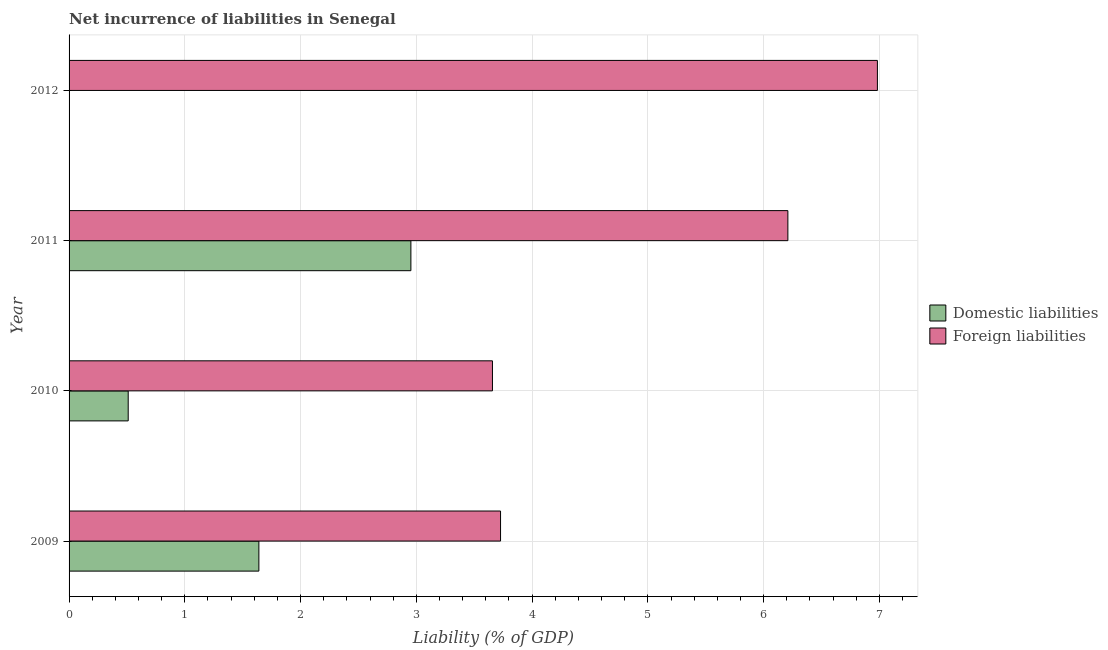How many different coloured bars are there?
Offer a terse response. 2. Are the number of bars per tick equal to the number of legend labels?
Provide a succinct answer. No. Are the number of bars on each tick of the Y-axis equal?
Give a very brief answer. No. In how many cases, is the number of bars for a given year not equal to the number of legend labels?
Offer a very short reply. 1. What is the incurrence of foreign liabilities in 2012?
Your response must be concise. 6.98. Across all years, what is the maximum incurrence of domestic liabilities?
Your answer should be compact. 2.95. In which year was the incurrence of foreign liabilities maximum?
Make the answer very short. 2012. What is the total incurrence of domestic liabilities in the graph?
Keep it short and to the point. 5.1. What is the difference between the incurrence of domestic liabilities in 2010 and that in 2011?
Provide a succinct answer. -2.44. What is the difference between the incurrence of foreign liabilities in 2011 and the incurrence of domestic liabilities in 2012?
Keep it short and to the point. 6.21. What is the average incurrence of domestic liabilities per year?
Offer a very short reply. 1.28. In the year 2011, what is the difference between the incurrence of domestic liabilities and incurrence of foreign liabilities?
Your response must be concise. -3.26. In how many years, is the incurrence of domestic liabilities greater than 6.6 %?
Your response must be concise. 0. What is the ratio of the incurrence of domestic liabilities in 2009 to that in 2010?
Your response must be concise. 3.21. Is the incurrence of foreign liabilities in 2009 less than that in 2010?
Provide a short and direct response. No. Is the difference between the incurrence of domestic liabilities in 2010 and 2011 greater than the difference between the incurrence of foreign liabilities in 2010 and 2011?
Give a very brief answer. Yes. What is the difference between the highest and the second highest incurrence of foreign liabilities?
Offer a terse response. 0.77. What is the difference between the highest and the lowest incurrence of foreign liabilities?
Your answer should be compact. 3.33. How many bars are there?
Give a very brief answer. 7. How many years are there in the graph?
Your answer should be compact. 4. What is the difference between two consecutive major ticks on the X-axis?
Provide a short and direct response. 1. Are the values on the major ticks of X-axis written in scientific E-notation?
Give a very brief answer. No. Does the graph contain any zero values?
Keep it short and to the point. Yes. Where does the legend appear in the graph?
Ensure brevity in your answer.  Center right. How many legend labels are there?
Provide a succinct answer. 2. What is the title of the graph?
Your answer should be very brief. Net incurrence of liabilities in Senegal. What is the label or title of the X-axis?
Keep it short and to the point. Liability (% of GDP). What is the Liability (% of GDP) in Domestic liabilities in 2009?
Your answer should be very brief. 1.64. What is the Liability (% of GDP) of Foreign liabilities in 2009?
Offer a terse response. 3.73. What is the Liability (% of GDP) of Domestic liabilities in 2010?
Make the answer very short. 0.51. What is the Liability (% of GDP) of Foreign liabilities in 2010?
Your response must be concise. 3.66. What is the Liability (% of GDP) in Domestic liabilities in 2011?
Provide a succinct answer. 2.95. What is the Liability (% of GDP) in Foreign liabilities in 2011?
Give a very brief answer. 6.21. What is the Liability (% of GDP) of Foreign liabilities in 2012?
Provide a short and direct response. 6.98. Across all years, what is the maximum Liability (% of GDP) of Domestic liabilities?
Offer a very short reply. 2.95. Across all years, what is the maximum Liability (% of GDP) in Foreign liabilities?
Give a very brief answer. 6.98. Across all years, what is the minimum Liability (% of GDP) in Domestic liabilities?
Keep it short and to the point. 0. Across all years, what is the minimum Liability (% of GDP) in Foreign liabilities?
Give a very brief answer. 3.66. What is the total Liability (% of GDP) in Domestic liabilities in the graph?
Your response must be concise. 5.1. What is the total Liability (% of GDP) of Foreign liabilities in the graph?
Provide a short and direct response. 20.58. What is the difference between the Liability (% of GDP) in Domestic liabilities in 2009 and that in 2010?
Give a very brief answer. 1.13. What is the difference between the Liability (% of GDP) of Foreign liabilities in 2009 and that in 2010?
Your answer should be very brief. 0.07. What is the difference between the Liability (% of GDP) in Domestic liabilities in 2009 and that in 2011?
Provide a succinct answer. -1.31. What is the difference between the Liability (% of GDP) of Foreign liabilities in 2009 and that in 2011?
Your response must be concise. -2.48. What is the difference between the Liability (% of GDP) in Foreign liabilities in 2009 and that in 2012?
Provide a short and direct response. -3.26. What is the difference between the Liability (% of GDP) of Domestic liabilities in 2010 and that in 2011?
Your response must be concise. -2.44. What is the difference between the Liability (% of GDP) of Foreign liabilities in 2010 and that in 2011?
Give a very brief answer. -2.55. What is the difference between the Liability (% of GDP) of Foreign liabilities in 2010 and that in 2012?
Keep it short and to the point. -3.33. What is the difference between the Liability (% of GDP) in Foreign liabilities in 2011 and that in 2012?
Keep it short and to the point. -0.77. What is the difference between the Liability (% of GDP) in Domestic liabilities in 2009 and the Liability (% of GDP) in Foreign liabilities in 2010?
Keep it short and to the point. -2.02. What is the difference between the Liability (% of GDP) in Domestic liabilities in 2009 and the Liability (% of GDP) in Foreign liabilities in 2011?
Give a very brief answer. -4.57. What is the difference between the Liability (% of GDP) of Domestic liabilities in 2009 and the Liability (% of GDP) of Foreign liabilities in 2012?
Give a very brief answer. -5.34. What is the difference between the Liability (% of GDP) of Domestic liabilities in 2010 and the Liability (% of GDP) of Foreign liabilities in 2011?
Ensure brevity in your answer.  -5.7. What is the difference between the Liability (% of GDP) of Domestic liabilities in 2010 and the Liability (% of GDP) of Foreign liabilities in 2012?
Keep it short and to the point. -6.47. What is the difference between the Liability (% of GDP) of Domestic liabilities in 2011 and the Liability (% of GDP) of Foreign liabilities in 2012?
Ensure brevity in your answer.  -4.03. What is the average Liability (% of GDP) in Domestic liabilities per year?
Give a very brief answer. 1.28. What is the average Liability (% of GDP) in Foreign liabilities per year?
Provide a short and direct response. 5.14. In the year 2009, what is the difference between the Liability (% of GDP) of Domestic liabilities and Liability (% of GDP) of Foreign liabilities?
Your answer should be very brief. -2.09. In the year 2010, what is the difference between the Liability (% of GDP) of Domestic liabilities and Liability (% of GDP) of Foreign liabilities?
Your answer should be very brief. -3.15. In the year 2011, what is the difference between the Liability (% of GDP) of Domestic liabilities and Liability (% of GDP) of Foreign liabilities?
Offer a terse response. -3.26. What is the ratio of the Liability (% of GDP) of Domestic liabilities in 2009 to that in 2010?
Give a very brief answer. 3.21. What is the ratio of the Liability (% of GDP) in Foreign liabilities in 2009 to that in 2010?
Make the answer very short. 1.02. What is the ratio of the Liability (% of GDP) of Domestic liabilities in 2009 to that in 2011?
Ensure brevity in your answer.  0.56. What is the ratio of the Liability (% of GDP) of Foreign liabilities in 2009 to that in 2011?
Make the answer very short. 0.6. What is the ratio of the Liability (% of GDP) in Foreign liabilities in 2009 to that in 2012?
Offer a terse response. 0.53. What is the ratio of the Liability (% of GDP) of Domestic liabilities in 2010 to that in 2011?
Your answer should be very brief. 0.17. What is the ratio of the Liability (% of GDP) of Foreign liabilities in 2010 to that in 2011?
Provide a succinct answer. 0.59. What is the ratio of the Liability (% of GDP) in Foreign liabilities in 2010 to that in 2012?
Provide a short and direct response. 0.52. What is the ratio of the Liability (% of GDP) of Foreign liabilities in 2011 to that in 2012?
Ensure brevity in your answer.  0.89. What is the difference between the highest and the second highest Liability (% of GDP) of Domestic liabilities?
Provide a short and direct response. 1.31. What is the difference between the highest and the second highest Liability (% of GDP) in Foreign liabilities?
Offer a terse response. 0.77. What is the difference between the highest and the lowest Liability (% of GDP) of Domestic liabilities?
Make the answer very short. 2.95. What is the difference between the highest and the lowest Liability (% of GDP) of Foreign liabilities?
Keep it short and to the point. 3.33. 